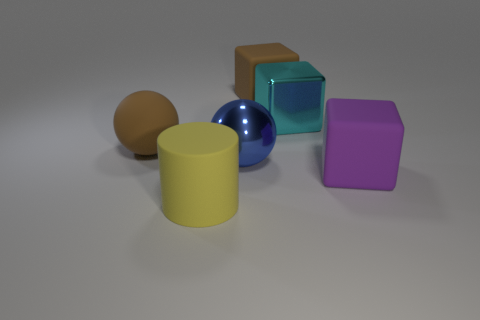Do the large matte block left of the cyan object and the large rubber ball have the same color?
Offer a very short reply. Yes. There is another large metal thing that is the same shape as the large purple thing; what is its color?
Ensure brevity in your answer.  Cyan. Do the brown object behind the large metal block and the large cyan metallic object have the same shape?
Provide a short and direct response. Yes. There is a sphere that is behind the metal thing that is left of the large brown rubber thing on the right side of the metal sphere; what is its color?
Provide a succinct answer. Brown. Is the material of the brown block the same as the sphere right of the large yellow matte cylinder?
Provide a succinct answer. No. What material is the brown sphere?
Ensure brevity in your answer.  Rubber. How many other things are made of the same material as the big brown sphere?
Offer a terse response. 3. There is a thing that is to the left of the blue metallic sphere and behind the large cylinder; what shape is it?
Give a very brief answer. Sphere. There is a cube that is the same material as the large blue thing; what is its color?
Your response must be concise. Cyan. Is the number of big cyan shiny things that are in front of the cyan shiny object the same as the number of tiny yellow objects?
Your answer should be very brief. Yes. 